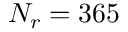<formula> <loc_0><loc_0><loc_500><loc_500>N _ { r } = 3 6 5</formula> 